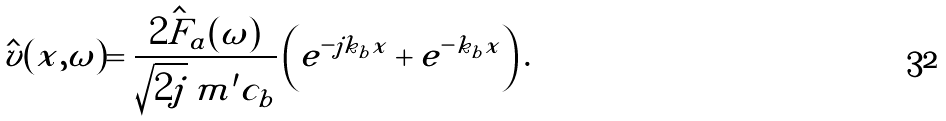Convert formula to latex. <formula><loc_0><loc_0><loc_500><loc_500>\hat { v } ( x , \omega ) = \frac { \hat { 2 F _ { a } } ( \omega ) } { \sqrt { 2 j } \, m ^ { \prime } c _ { b } } \left ( e ^ { - j k _ { b } x } + e ^ { - k _ { b } x } \right ) .</formula> 